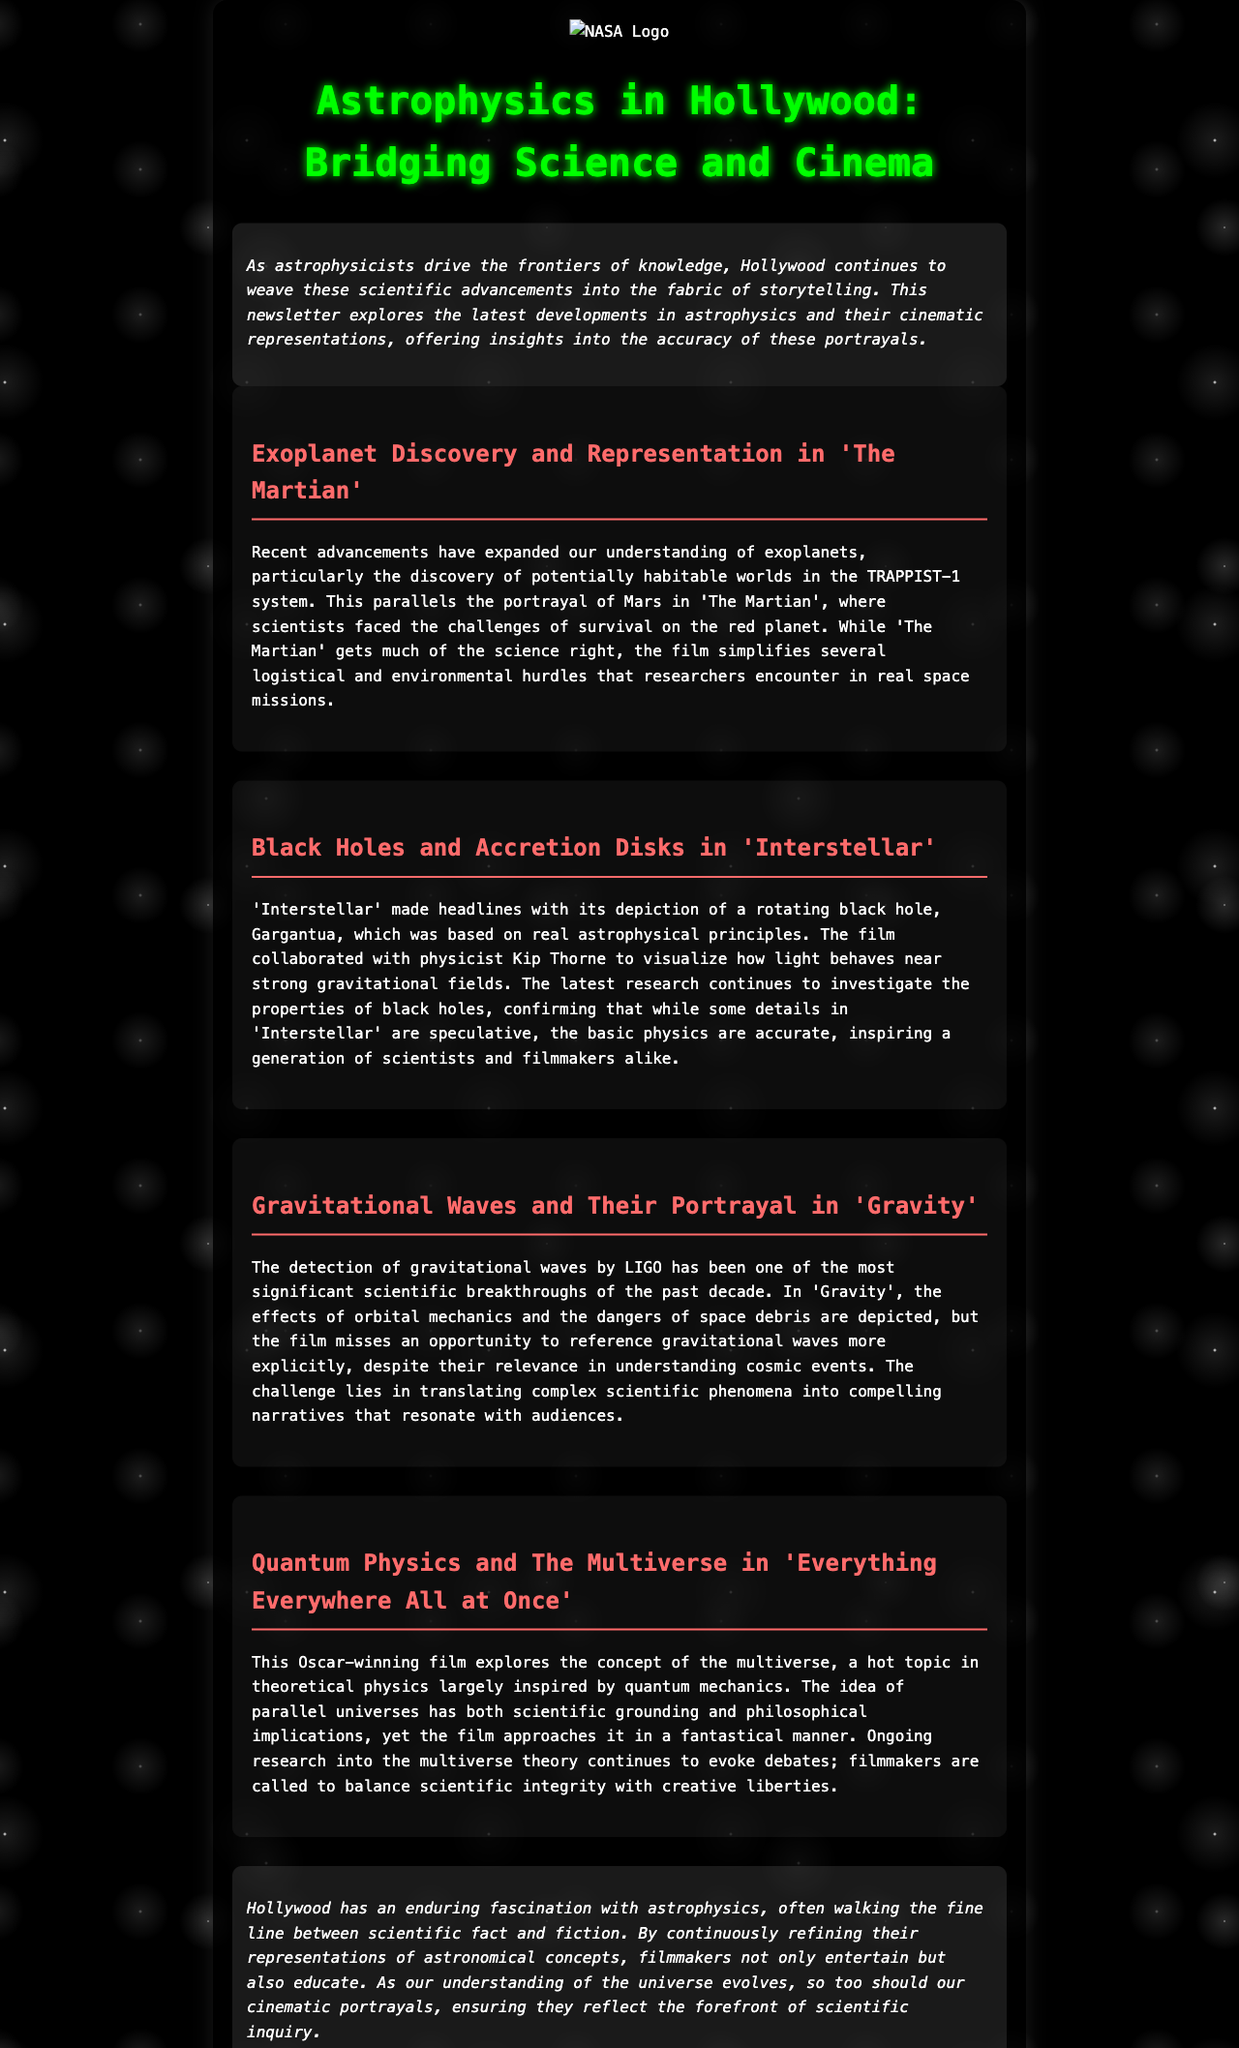what is the title of the newsletter? The title of the newsletter is mentioned at the beginning of the document.
Answer: Astrophysics in Hollywood: Bridging Science and Cinema who collaborated with 'Interstellar' to visualize light behavior near black holes? The document states that the film 'Interstellar' collaborated with a notable physicist for visualizations.
Answer: Kip Thorne what significant scientific breakthrough is mentioned in relation to LIGO? The document highlights a major discovery associated with LIGO that has changed the astrophysics landscape.
Answer: Gravitational waves which film explores the concept of the multiverse? The newsletter discusses a film that delves into theoretical physics and the multiverse concept.
Answer: Everything Everywhere All at Once what planetary system expansion is mentioned in the context of exoplanets? The document refers to a specific system where potentially habitable worlds were found.
Answer: TRAPPIST-1 how does 'The Martian' portray survival challenges? The newsletter notes that while 'The Martian' gets much science right, there are challenges simplified in the film.
Answer: Logistical and environmental hurdles which film received an Oscar and is mentioned in connection to quantum physics? The newsletter highlights a specific award-winning film relevant to contemporary scientific discussions.
Answer: Everything Everywhere All at Once what does Hollywood often balance in their portrayals of astrophysics? The newsletter discusses the challenge filmmakers face in representing complex scientific phenomena.
Answer: Scientific fact and fiction 